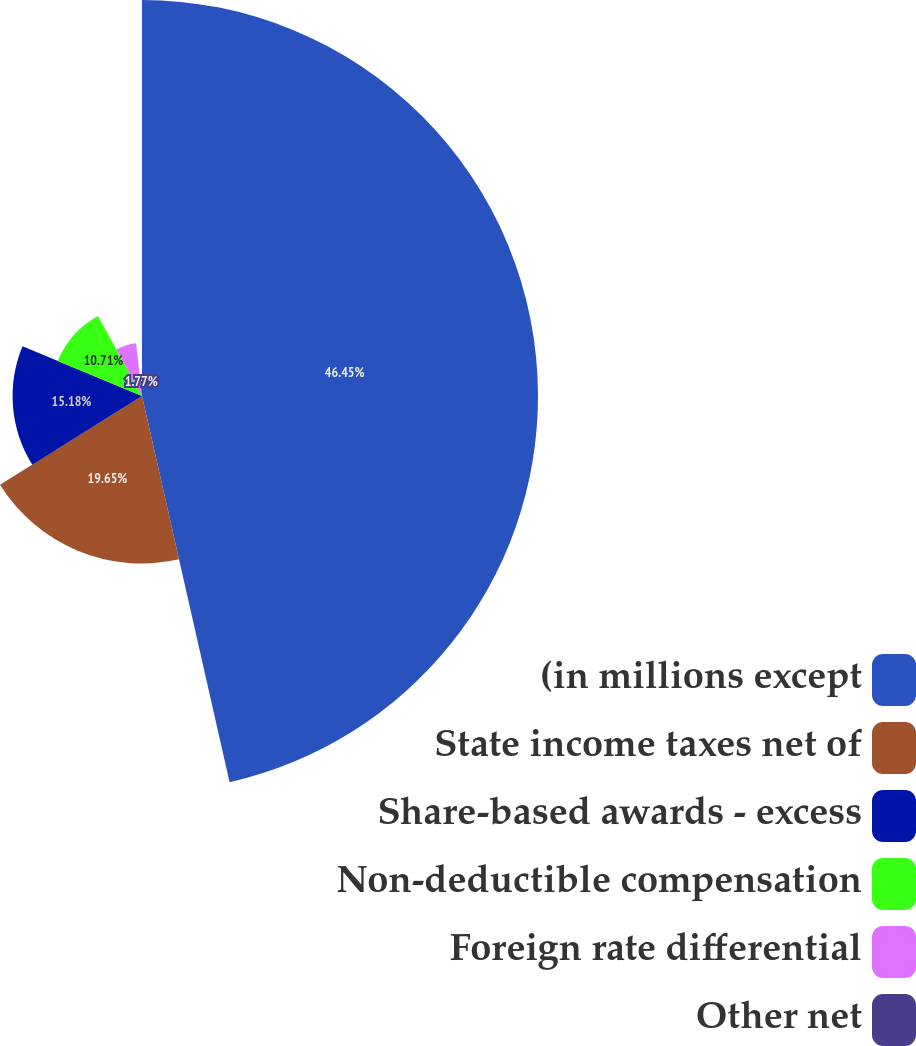Convert chart. <chart><loc_0><loc_0><loc_500><loc_500><pie_chart><fcel>(in millions except<fcel>State income taxes net of<fcel>Share-based awards - excess<fcel>Non-deductible compensation<fcel>Foreign rate differential<fcel>Other net<nl><fcel>46.45%<fcel>19.65%<fcel>15.18%<fcel>10.71%<fcel>6.24%<fcel>1.77%<nl></chart> 